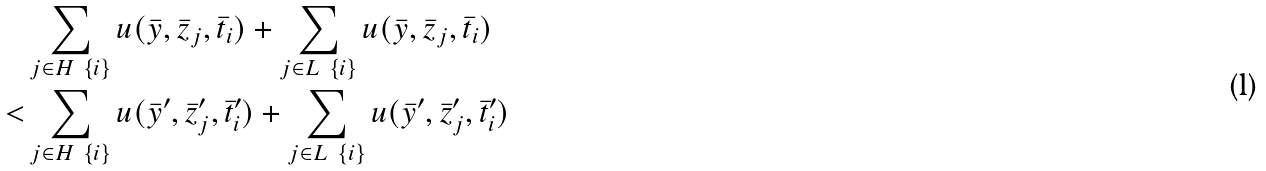Convert formula to latex. <formula><loc_0><loc_0><loc_500><loc_500>& \sum _ { j \in H \ \{ i \} } u ( \bar { y } , \bar { z } _ { j } , \bar { t } _ { i } ) + \sum _ { j \in L \ \{ i \} } u ( \bar { y } , \bar { z } _ { j } , \bar { t } _ { i } ) \\ < & \sum _ { j \in H \ \{ i \} } u ( \bar { y } ^ { \prime } , \bar { z } ^ { \prime } _ { j } , \bar { t } ^ { \prime } _ { i } ) + \sum _ { j \in L \ \{ i \} } u ( \bar { y } ^ { \prime } , \bar { z } ^ { \prime } _ { j } , \bar { t } ^ { \prime } _ { i } )</formula> 